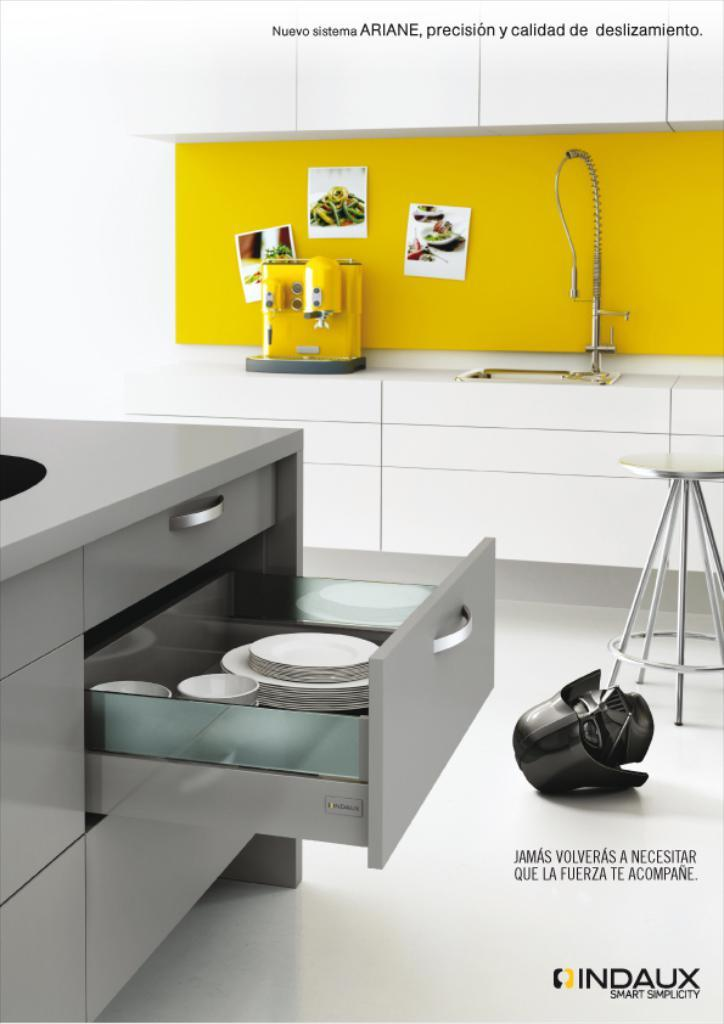<image>
Offer a succinct explanation of the picture presented. Kitchen with a yellow board that says Nuevo Sistema" above it. 